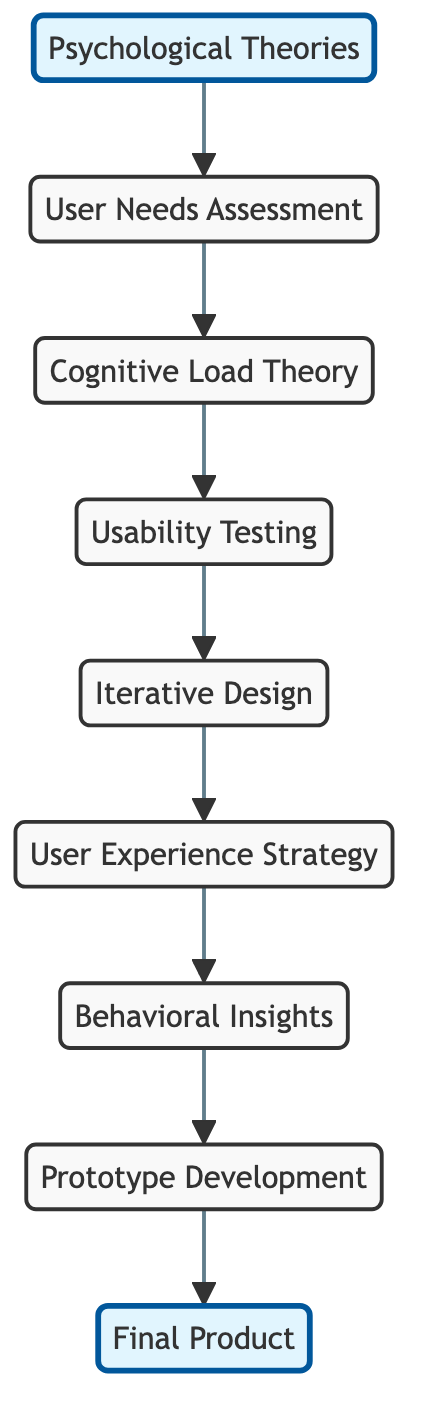What is the starting point of the pathway? The diagram begins with the "Psychological Theories" node, which is the first node in the flow and has outgoing edges leading to "User Needs Assessment."
Answer: Psychological Theories How many nodes are there in total? By counting the nodes listed in the diagram, there are nine distinct nodes: "Psychological Theories," "User Needs Assessment," "Cognitive Load Theory," "Usability Testing," "Iterative Design," "User Experience Strategy," "Behavioral Insights," "Prototype Development," and "Final Product."
Answer: 9 What is the final node in the pathway? The last node in the pathway, where all the processes lead, is "Final Product," which does not lead to any further nodes.
Answer: Final Product Which nodes are connected directly to "Cognitive Load Theory"? The nodes that are directly connected to "Cognitive Load Theory" are "User Needs Assessment," which leads into it, and "Usability Testing," which it connects to.
Answer: Usability Testing How many edges are there in the diagram? By counting the edges connecting nodes, there are eight directed edges that represent the pathways from one node to the next throughout the diagram.
Answer: 8 What is the relationship between “Behavioral Insights” and “Prototype Development”? "Behavioral Insights" serves as a prerequisite to "Prototype Development," as it is directly connected with an outgoing edge. Hence, the pathway flows from "Behavioral Insights" to "Prototype Development."
Answer: leads to What is the sequence of stages starting from "Psychological Theories" to "Final Product"? The sequence of stages is: "Psychological Theories" → "User Needs Assessment" → "Cognitive Load Theory" → "Usability Testing" → "Iterative Design" → "User Experience Strategy" → "Behavioral Insights" → "Prototype Development" → "Final Product." This is based on following the directed edges from the start to the final node.
Answer: Psychological Theories, User Needs Assessment, Cognitive Load Theory, Usability Testing, Iterative Design, User Experience Strategy, Behavioral Insights, Prototype Development, Final Product Which node immediately follows "User Experience Strategy"? Following "User Experience Strategy," the next node in the pathway is "Behavioral Insights," as indicated by the directed edge connecting them.
Answer: Behavioral Insights What stage is directly before "Final Product"? The stage immediately preceding "Final Product" is "Prototype Development," which connects directly to the final stage with an incoming edge.
Answer: Prototype Development 